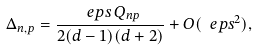<formula> <loc_0><loc_0><loc_500><loc_500>\Delta _ { n , p } = \frac { \ e p s \, Q _ { n p } } { 2 ( d - 1 ) ( d + 2 ) } + O ( \ e p s ^ { 2 } ) ,</formula> 